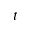<formula> <loc_0><loc_0><loc_500><loc_500>t</formula> 